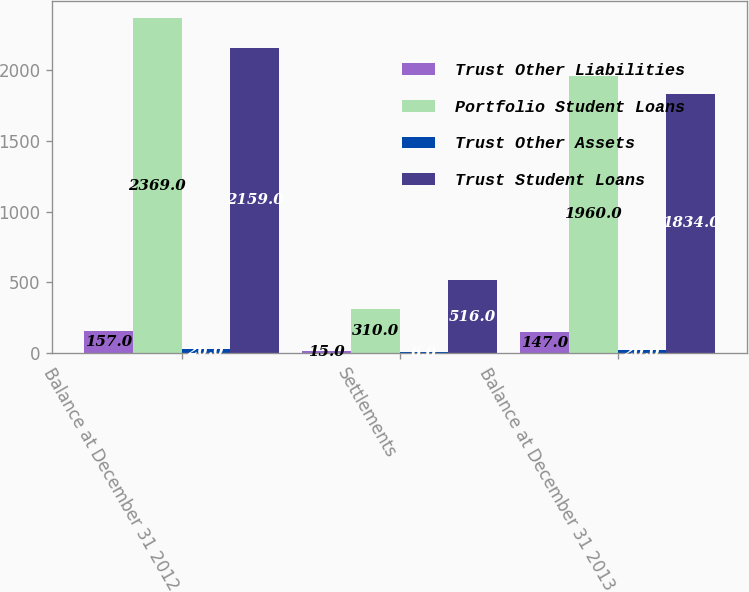Convert chart to OTSL. <chart><loc_0><loc_0><loc_500><loc_500><stacked_bar_chart><ecel><fcel>Balance at December 31 2012<fcel>Settlements<fcel>Balance at December 31 2013<nl><fcel>Trust Other Liabilities<fcel>157<fcel>15<fcel>147<nl><fcel>Portfolio Student Loans<fcel>2369<fcel>310<fcel>1960<nl><fcel>Trust Other Assets<fcel>26<fcel>6<fcel>20<nl><fcel>Trust Student Loans<fcel>2159<fcel>516<fcel>1834<nl></chart> 